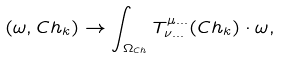Convert formula to latex. <formula><loc_0><loc_0><loc_500><loc_500>( \omega , C h _ { k } ) \to \int _ { \Omega _ { C h } } T ^ { \mu \dots } _ { \nu \dots } ( C h _ { k } ) \cdot \omega ,</formula> 